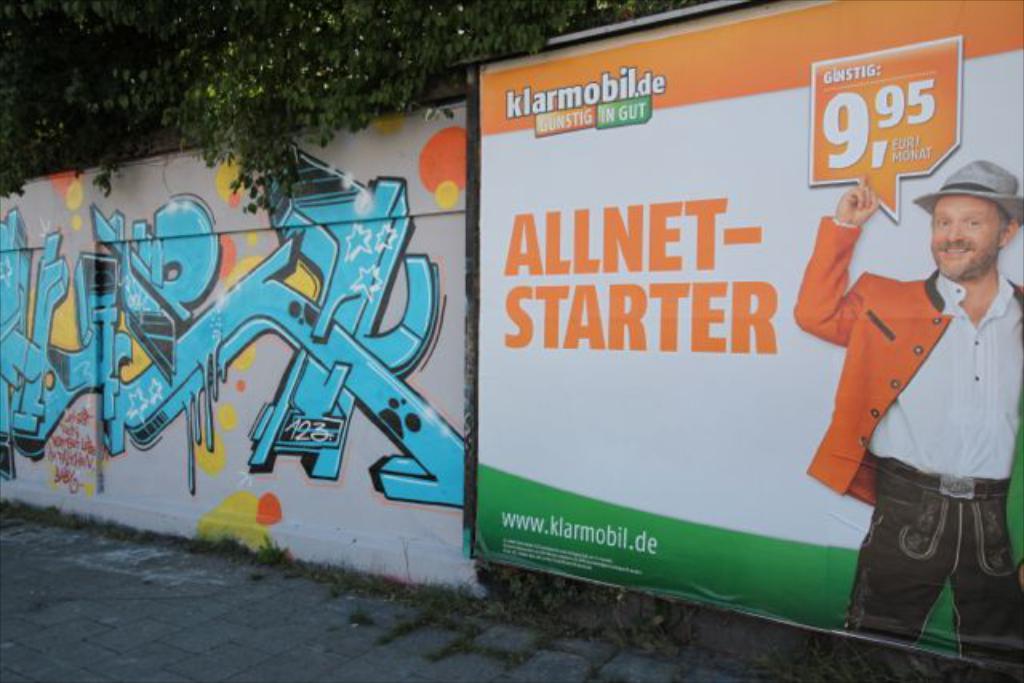What is the amount on the poster?
Make the answer very short. 9.95. What is the website shown at the bottom of the poster?
Ensure brevity in your answer.  Www.klarmobil.de. 